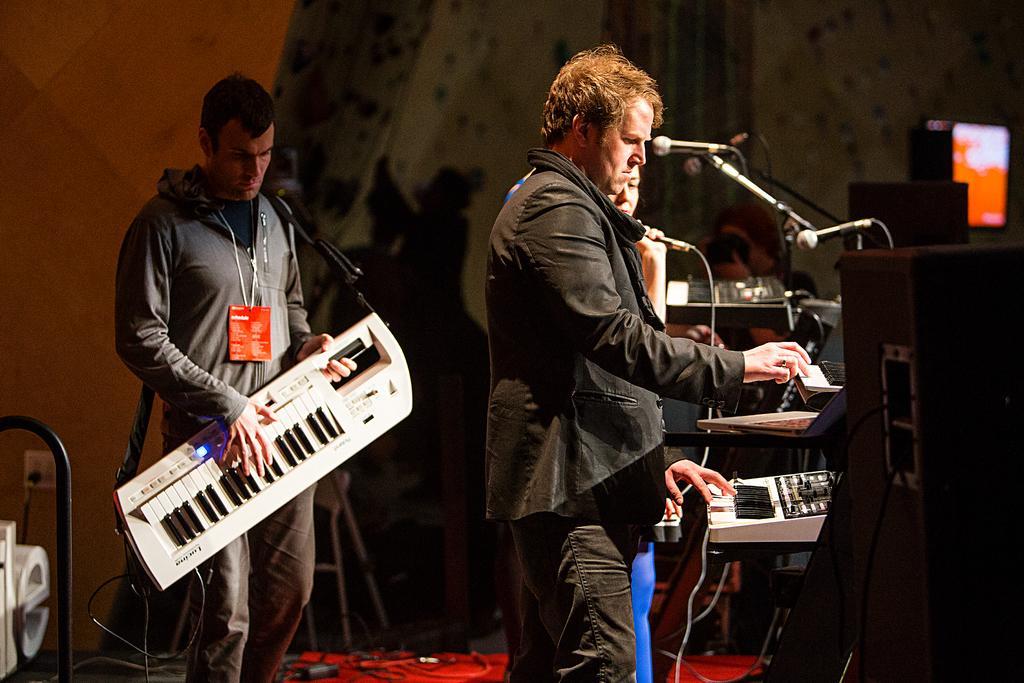Could you give a brief overview of what you see in this image? On the left side, there is a person in gray color t-shirt holding a keyboard and playing and standing on a stage. On the right side, there is a speaker, there are mice attached to the stands and there are persons standing, one of the is playing keyboards and other one is holding a mic. In the background, there are cables on the red color carpet, a curtain and an yellow color wall. 